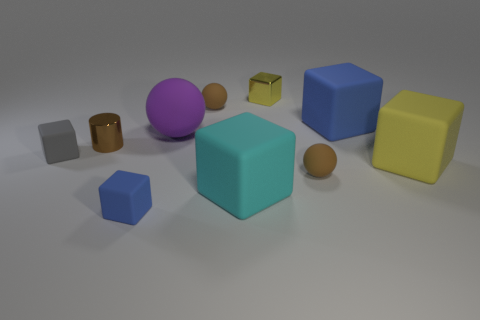What could be the function of these objects if they were part of a game environment? Within a game environment, these objects could serve various purposes. The colorful blocks could represent collectible items or building blocks for constructing structures or solving puzzles. The spheres might serve as projectiles or orbs to be collected for points, and the cubes could function as elements within the environment that the player can interact with, like moving them to reach higher platforms or fit them into spaces to unlock a new level. 